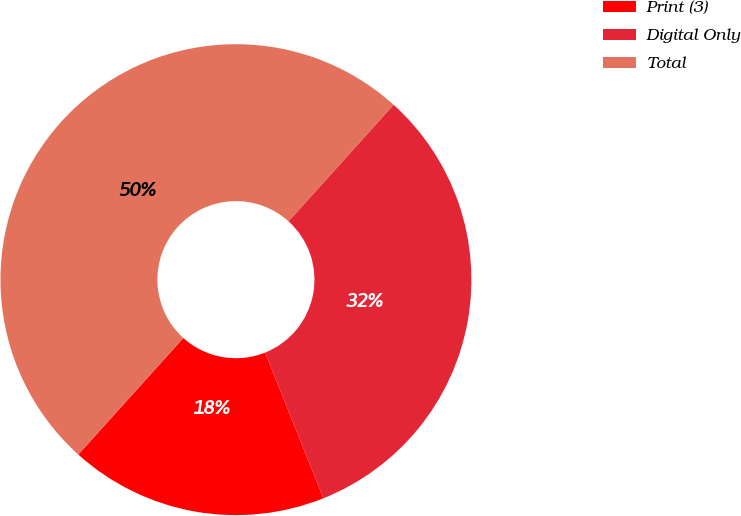Convert chart. <chart><loc_0><loc_0><loc_500><loc_500><pie_chart><fcel>Print (3)<fcel>Digital Only<fcel>Total<nl><fcel>17.73%<fcel>32.27%<fcel>50.0%<nl></chart> 